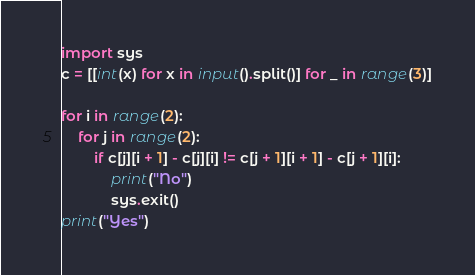Convert code to text. <code><loc_0><loc_0><loc_500><loc_500><_Python_>import sys
c = [[int(x) for x in input().split()] for _ in range(3)]

for i in range(2):
    for j in range(2):
        if c[j][i + 1] - c[j][i] != c[j + 1][i + 1] - c[j + 1][i]:
            print("No")
            sys.exit()
print("Yes")</code> 